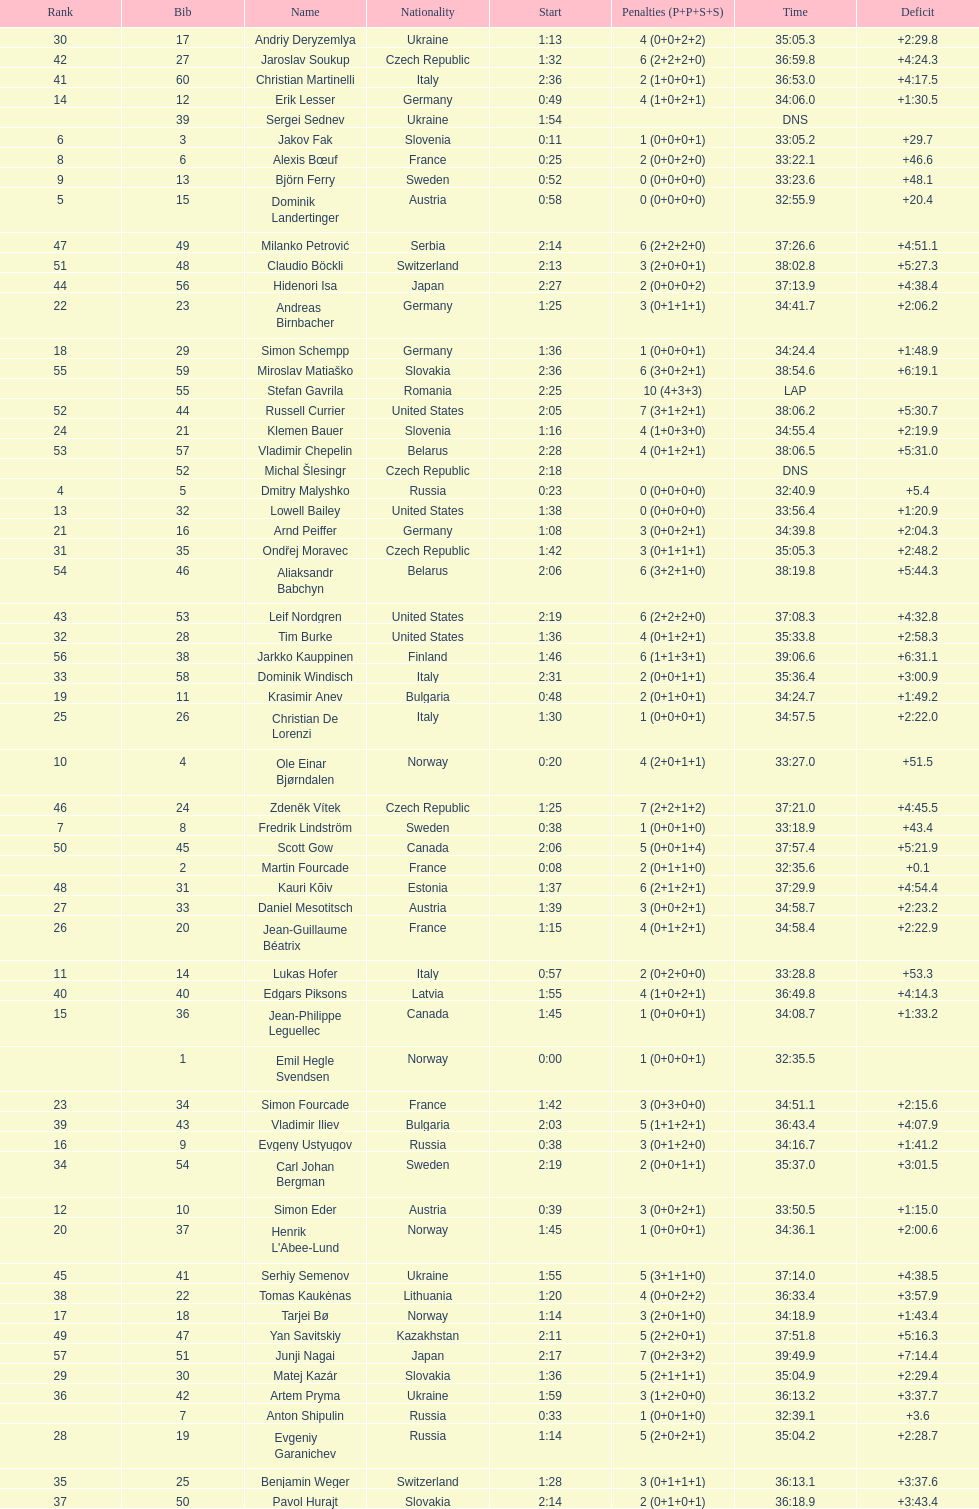Other than burke, name an athlete from the us. Leif Nordgren. 